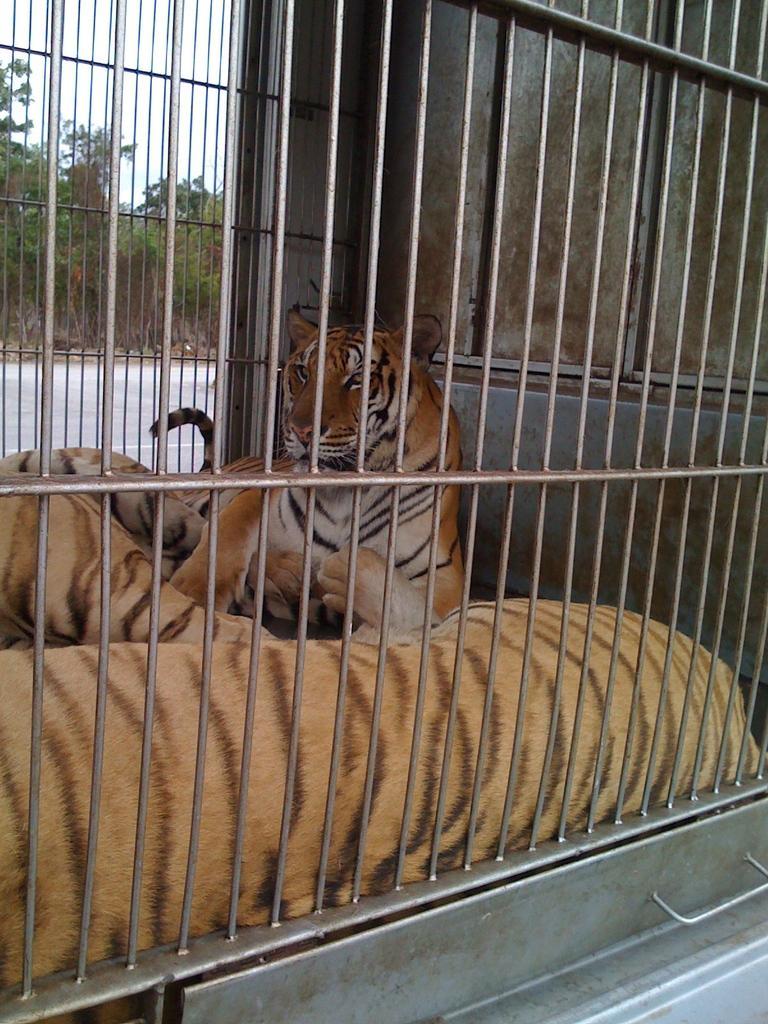Can you describe this image briefly? In this image we can see some tigers inside the metal cage. On the left side we can see the road, a group of trees and the sky which looks cloudy. 